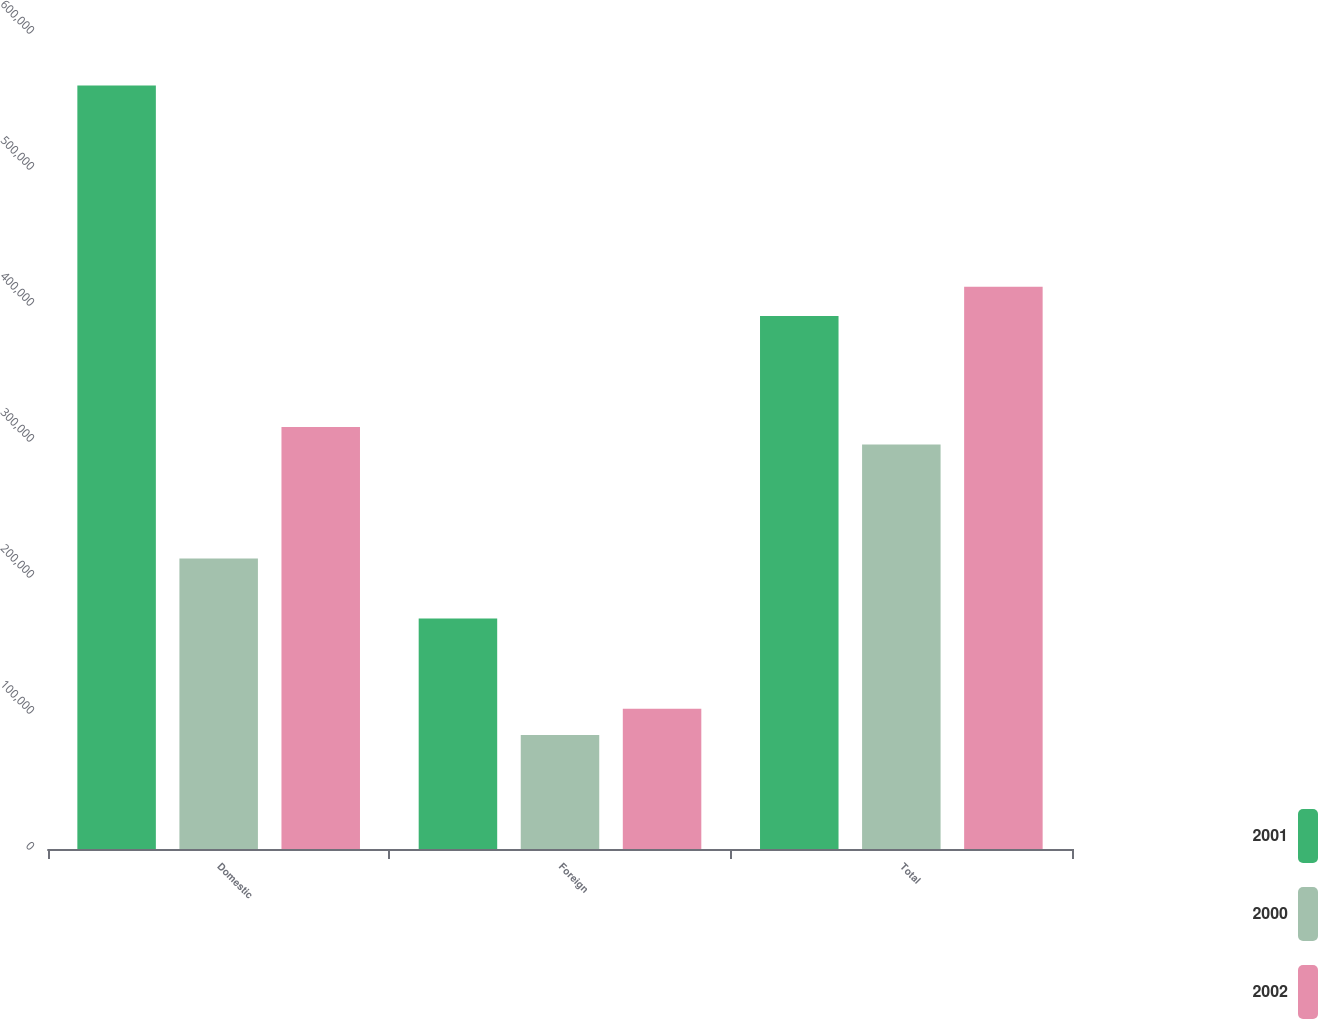Convert chart to OTSL. <chart><loc_0><loc_0><loc_500><loc_500><stacked_bar_chart><ecel><fcel>Domestic<fcel>Foreign<fcel>Total<nl><fcel>2001<fcel>561409<fcel>169476<fcel>391933<nl><fcel>2000<fcel>213689<fcel>83763<fcel>297452<nl><fcel>2002<fcel>310361<fcel>103068<fcel>413429<nl></chart> 